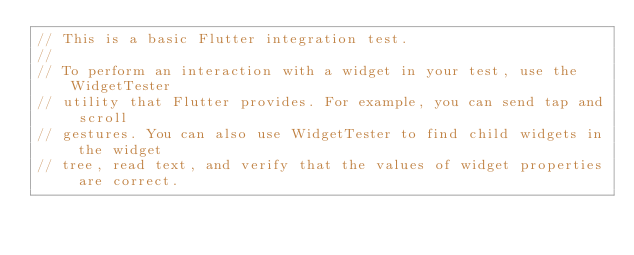<code> <loc_0><loc_0><loc_500><loc_500><_Dart_>// This is a basic Flutter integration test.
//
// To perform an interaction with a widget in your test, use the WidgetTester
// utility that Flutter provides. For example, you can send tap and scroll
// gestures. You can also use WidgetTester to find child widgets in the widget
// tree, read text, and verify that the values of widget properties are correct.
</code> 